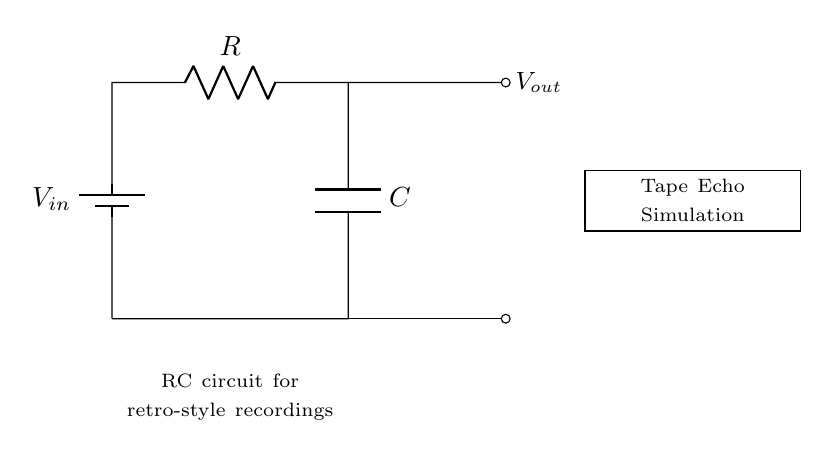What is the input voltage? The input voltage is labeled as \( V_{in} \), which represents the voltage supplied to the circuit.
Answer: \( V_{in} \) What is the component used for storing energy? The component used for storing energy in this circuit is labeled as \( C \), which indicates a capacitor.
Answer: \( C \) What type of circuit does this represent? The circuit diagram represents an RC circuit, which is a combination of resistors and capacitors.
Answer: RC circuit What does the output voltage represent? The output voltage \( V_{out} \) is taken from the point after the resistor and before the capacitor, indicating the voltage drop across the capacitor.
Answer: \( V_{out} \) Which component controls the time constant of the circuit? The resistor \( R \) and capacitor \( C \) together determine the time constant, represented by the formula \( \tau = R \cdot C \).
Answer: \( R \) and \( C \) How is the capacitor connected in the circuit? The capacitor is connected in parallel with the output and the resistor, allowing it to store voltage over time.
Answer: Parallel connection What type of simulation is indicated in the circuit? The circuit is indicated as a simulation for tape echo, which suggests it mimics the feedback effect found in vintage tape recording systems.
Answer: Tape Echo Simulation 